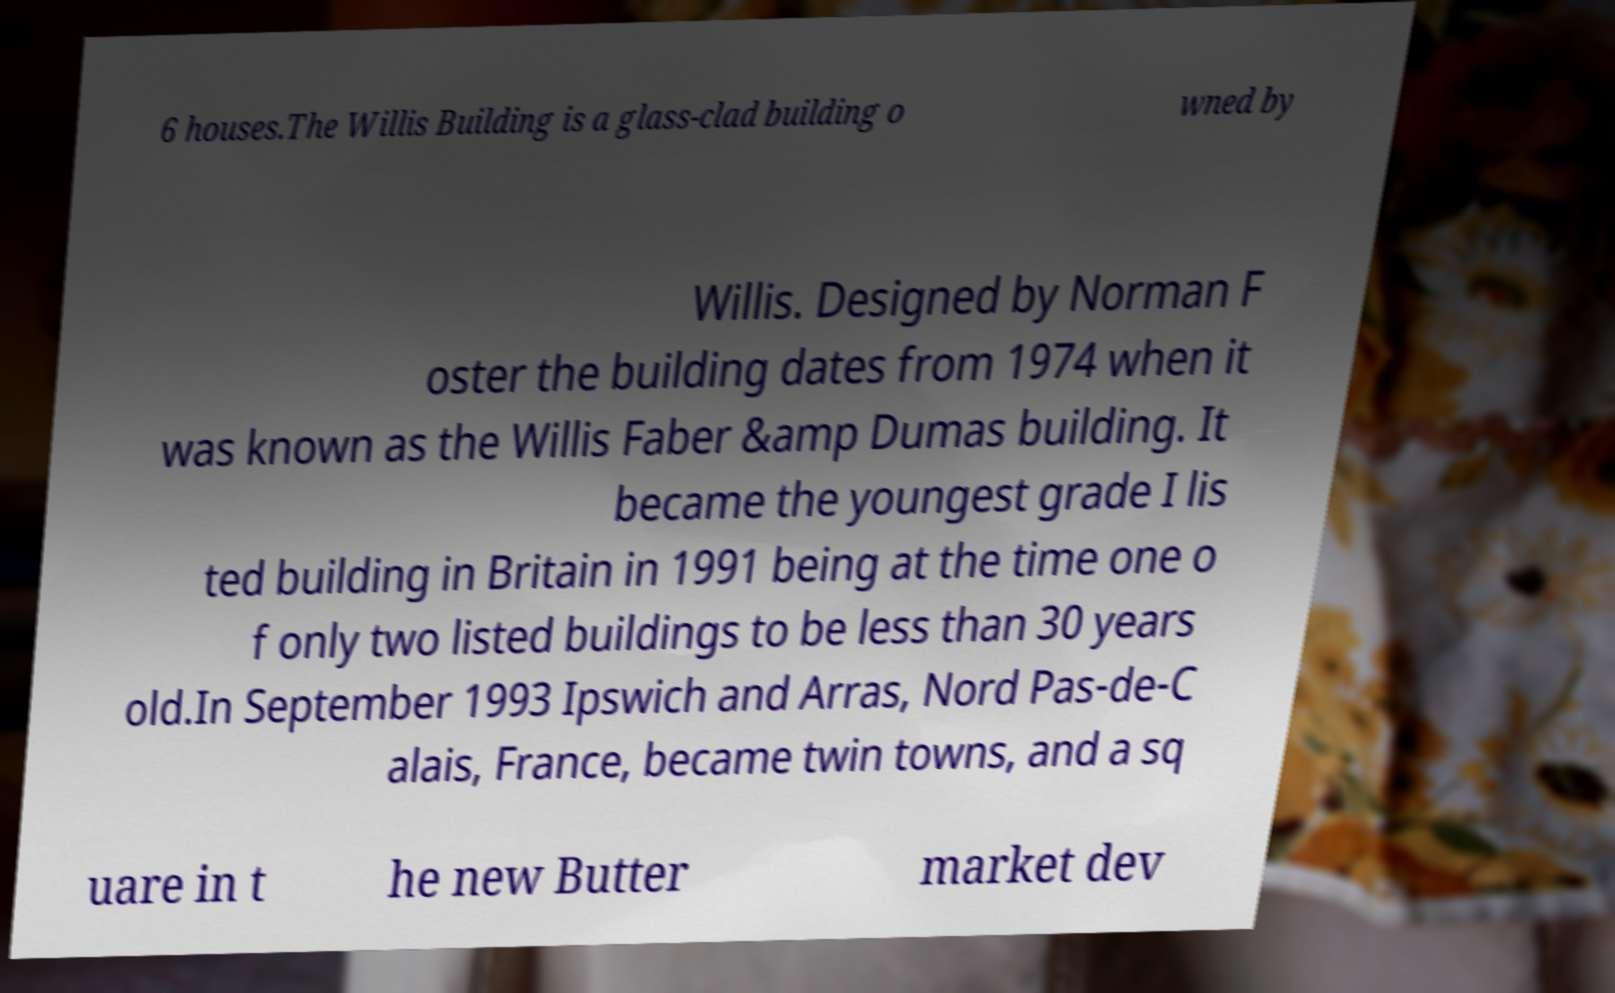There's text embedded in this image that I need extracted. Can you transcribe it verbatim? 6 houses.The Willis Building is a glass-clad building o wned by Willis. Designed by Norman F oster the building dates from 1974 when it was known as the Willis Faber &amp Dumas building. It became the youngest grade I lis ted building in Britain in 1991 being at the time one o f only two listed buildings to be less than 30 years old.In September 1993 Ipswich and Arras, Nord Pas-de-C alais, France, became twin towns, and a sq uare in t he new Butter market dev 